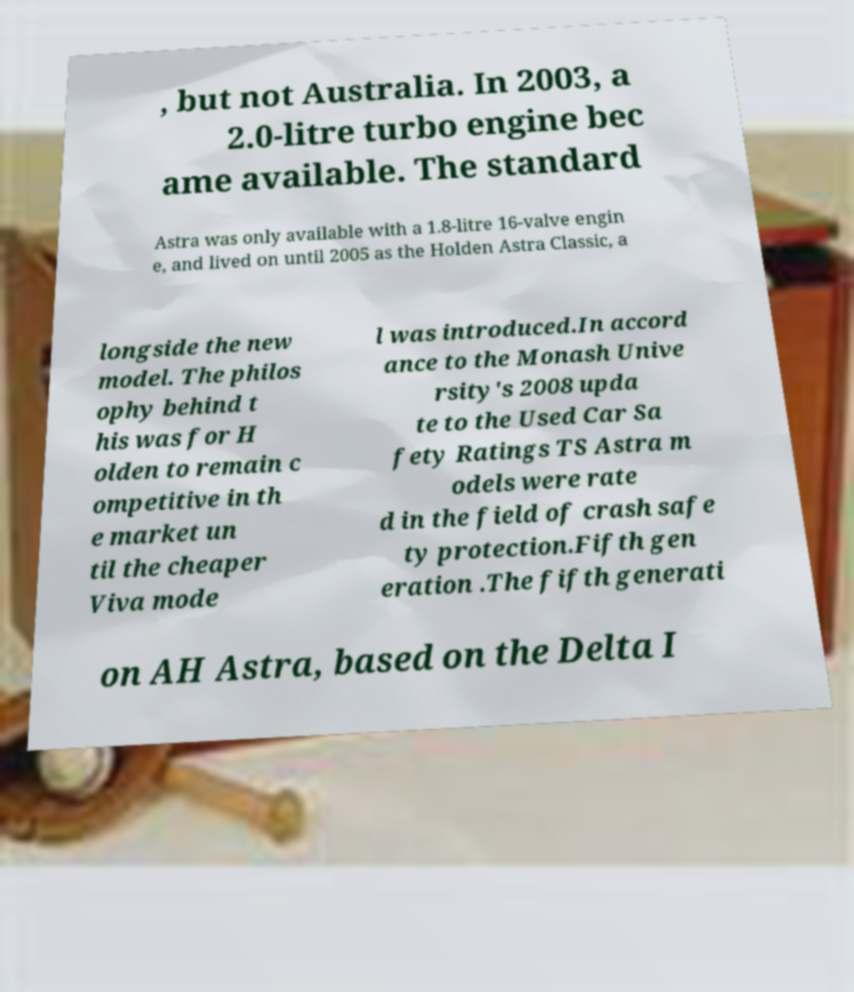I need the written content from this picture converted into text. Can you do that? , but not Australia. In 2003, a 2.0-litre turbo engine bec ame available. The standard Astra was only available with a 1.8-litre 16-valve engin e, and lived on until 2005 as the Holden Astra Classic, a longside the new model. The philos ophy behind t his was for H olden to remain c ompetitive in th e market un til the cheaper Viva mode l was introduced.In accord ance to the Monash Unive rsity's 2008 upda te to the Used Car Sa fety Ratings TS Astra m odels were rate d in the field of crash safe ty protection.Fifth gen eration .The fifth generati on AH Astra, based on the Delta I 